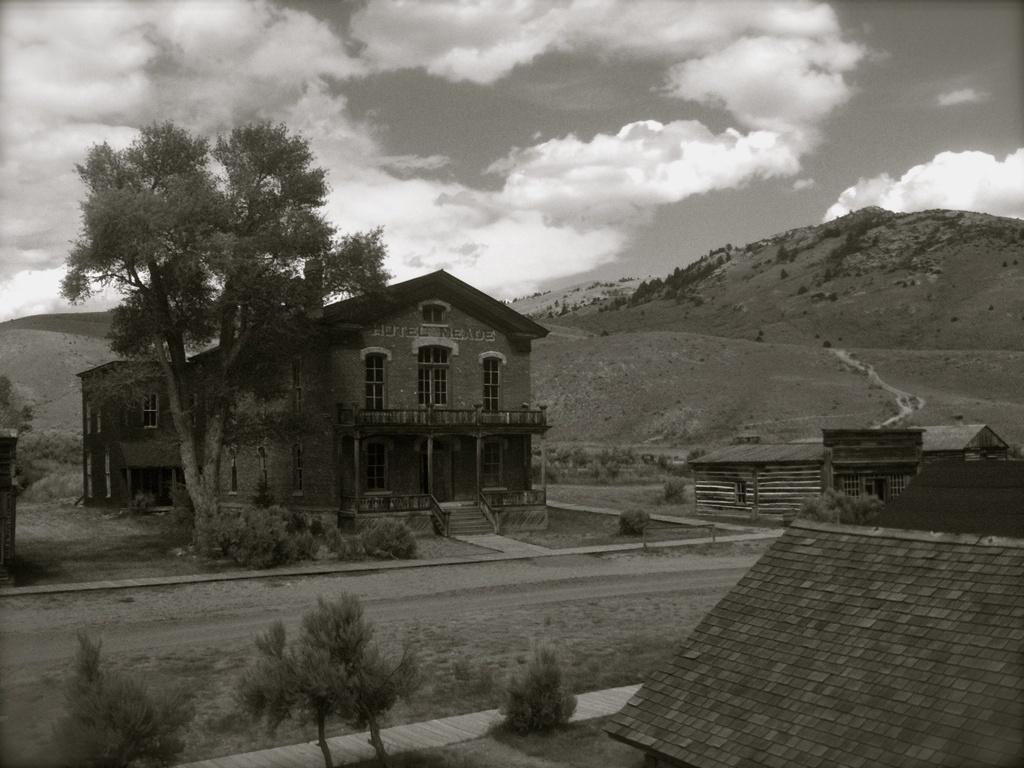What type of structure is visible in the image? There is a building in the image. What natural element is present in the image? There is a tree in the image. What geographical feature can be seen in the distance? There is a mountain in the backdrop of the image. What is the condition of the sky in the image? The sky is clear in the image. How many fingers can be seen pointing at the building in the image? There are no fingers visible in the image, as it only features a building, a tree, a mountain, and a clear sky. 